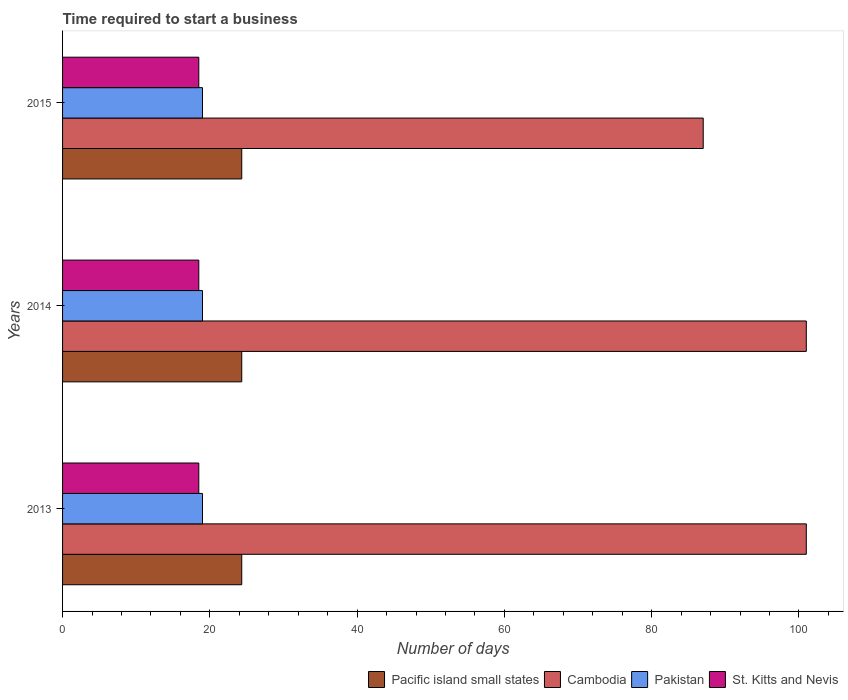Are the number of bars on each tick of the Y-axis equal?
Provide a succinct answer. Yes. How many bars are there on the 2nd tick from the top?
Provide a succinct answer. 4. How many bars are there on the 2nd tick from the bottom?
Provide a succinct answer. 4. What is the label of the 2nd group of bars from the top?
Provide a short and direct response. 2014. In how many cases, is the number of bars for a given year not equal to the number of legend labels?
Provide a short and direct response. 0. What is the number of days required to start a business in Cambodia in 2015?
Your answer should be very brief. 87. Across all years, what is the minimum number of days required to start a business in Pacific island small states?
Provide a succinct answer. 24.33. In which year was the number of days required to start a business in Pacific island small states maximum?
Your answer should be very brief. 2013. What is the total number of days required to start a business in St. Kitts and Nevis in the graph?
Your response must be concise. 55.5. What is the difference between the number of days required to start a business in Pakistan in 2013 and that in 2014?
Your response must be concise. 0. What is the average number of days required to start a business in Pakistan per year?
Provide a succinct answer. 19. In the year 2014, what is the difference between the number of days required to start a business in Pacific island small states and number of days required to start a business in St. Kitts and Nevis?
Your answer should be very brief. 5.83. In how many years, is the number of days required to start a business in Pakistan greater than 32 days?
Keep it short and to the point. 0. Is the number of days required to start a business in Pacific island small states in 2013 less than that in 2015?
Give a very brief answer. No. Is the difference between the number of days required to start a business in Pacific island small states in 2013 and 2014 greater than the difference between the number of days required to start a business in St. Kitts and Nevis in 2013 and 2014?
Your answer should be very brief. No. What is the difference between the highest and the lowest number of days required to start a business in Cambodia?
Your response must be concise. 14. Is the sum of the number of days required to start a business in Cambodia in 2013 and 2014 greater than the maximum number of days required to start a business in St. Kitts and Nevis across all years?
Your answer should be very brief. Yes. What does the 2nd bar from the bottom in 2014 represents?
Provide a succinct answer. Cambodia. Are all the bars in the graph horizontal?
Keep it short and to the point. Yes. How many years are there in the graph?
Provide a succinct answer. 3. Does the graph contain grids?
Ensure brevity in your answer.  No. How many legend labels are there?
Offer a very short reply. 4. How are the legend labels stacked?
Your response must be concise. Horizontal. What is the title of the graph?
Offer a terse response. Time required to start a business. What is the label or title of the X-axis?
Your answer should be compact. Number of days. What is the label or title of the Y-axis?
Provide a succinct answer. Years. What is the Number of days in Pacific island small states in 2013?
Offer a very short reply. 24.33. What is the Number of days in Cambodia in 2013?
Your response must be concise. 101. What is the Number of days of Pakistan in 2013?
Make the answer very short. 19. What is the Number of days of St. Kitts and Nevis in 2013?
Your response must be concise. 18.5. What is the Number of days in Pacific island small states in 2014?
Keep it short and to the point. 24.33. What is the Number of days in Cambodia in 2014?
Offer a very short reply. 101. What is the Number of days of Pacific island small states in 2015?
Offer a terse response. 24.33. What is the Number of days in Cambodia in 2015?
Provide a short and direct response. 87. What is the Number of days of St. Kitts and Nevis in 2015?
Make the answer very short. 18.5. Across all years, what is the maximum Number of days of Pacific island small states?
Provide a short and direct response. 24.33. Across all years, what is the maximum Number of days in Cambodia?
Your answer should be compact. 101. Across all years, what is the maximum Number of days of Pakistan?
Offer a terse response. 19. Across all years, what is the maximum Number of days of St. Kitts and Nevis?
Offer a very short reply. 18.5. Across all years, what is the minimum Number of days of Pacific island small states?
Offer a terse response. 24.33. Across all years, what is the minimum Number of days in St. Kitts and Nevis?
Keep it short and to the point. 18.5. What is the total Number of days of Pacific island small states in the graph?
Offer a very short reply. 73. What is the total Number of days of Cambodia in the graph?
Keep it short and to the point. 289. What is the total Number of days in Pakistan in the graph?
Offer a terse response. 57. What is the total Number of days in St. Kitts and Nevis in the graph?
Give a very brief answer. 55.5. What is the difference between the Number of days of Cambodia in 2014 and that in 2015?
Your response must be concise. 14. What is the difference between the Number of days in Pakistan in 2014 and that in 2015?
Make the answer very short. 0. What is the difference between the Number of days in Pacific island small states in 2013 and the Number of days in Cambodia in 2014?
Offer a very short reply. -76.67. What is the difference between the Number of days in Pacific island small states in 2013 and the Number of days in Pakistan in 2014?
Provide a succinct answer. 5.33. What is the difference between the Number of days of Pacific island small states in 2013 and the Number of days of St. Kitts and Nevis in 2014?
Provide a short and direct response. 5.83. What is the difference between the Number of days in Cambodia in 2013 and the Number of days in Pakistan in 2014?
Your answer should be compact. 82. What is the difference between the Number of days of Cambodia in 2013 and the Number of days of St. Kitts and Nevis in 2014?
Your response must be concise. 82.5. What is the difference between the Number of days in Pacific island small states in 2013 and the Number of days in Cambodia in 2015?
Offer a very short reply. -62.67. What is the difference between the Number of days in Pacific island small states in 2013 and the Number of days in Pakistan in 2015?
Your answer should be compact. 5.33. What is the difference between the Number of days in Pacific island small states in 2013 and the Number of days in St. Kitts and Nevis in 2015?
Your answer should be very brief. 5.83. What is the difference between the Number of days of Cambodia in 2013 and the Number of days of Pakistan in 2015?
Keep it short and to the point. 82. What is the difference between the Number of days of Cambodia in 2013 and the Number of days of St. Kitts and Nevis in 2015?
Make the answer very short. 82.5. What is the difference between the Number of days in Pakistan in 2013 and the Number of days in St. Kitts and Nevis in 2015?
Provide a short and direct response. 0.5. What is the difference between the Number of days in Pacific island small states in 2014 and the Number of days in Cambodia in 2015?
Offer a very short reply. -62.67. What is the difference between the Number of days of Pacific island small states in 2014 and the Number of days of Pakistan in 2015?
Your answer should be compact. 5.33. What is the difference between the Number of days of Pacific island small states in 2014 and the Number of days of St. Kitts and Nevis in 2015?
Ensure brevity in your answer.  5.83. What is the difference between the Number of days of Cambodia in 2014 and the Number of days of Pakistan in 2015?
Give a very brief answer. 82. What is the difference between the Number of days in Cambodia in 2014 and the Number of days in St. Kitts and Nevis in 2015?
Your answer should be very brief. 82.5. What is the average Number of days of Pacific island small states per year?
Offer a very short reply. 24.33. What is the average Number of days of Cambodia per year?
Keep it short and to the point. 96.33. What is the average Number of days of Pakistan per year?
Keep it short and to the point. 19. In the year 2013, what is the difference between the Number of days of Pacific island small states and Number of days of Cambodia?
Your response must be concise. -76.67. In the year 2013, what is the difference between the Number of days in Pacific island small states and Number of days in Pakistan?
Provide a succinct answer. 5.33. In the year 2013, what is the difference between the Number of days of Pacific island small states and Number of days of St. Kitts and Nevis?
Provide a short and direct response. 5.83. In the year 2013, what is the difference between the Number of days of Cambodia and Number of days of St. Kitts and Nevis?
Your answer should be very brief. 82.5. In the year 2014, what is the difference between the Number of days of Pacific island small states and Number of days of Cambodia?
Your answer should be very brief. -76.67. In the year 2014, what is the difference between the Number of days in Pacific island small states and Number of days in Pakistan?
Make the answer very short. 5.33. In the year 2014, what is the difference between the Number of days of Pacific island small states and Number of days of St. Kitts and Nevis?
Offer a very short reply. 5.83. In the year 2014, what is the difference between the Number of days of Cambodia and Number of days of Pakistan?
Provide a short and direct response. 82. In the year 2014, what is the difference between the Number of days of Cambodia and Number of days of St. Kitts and Nevis?
Provide a short and direct response. 82.5. In the year 2015, what is the difference between the Number of days of Pacific island small states and Number of days of Cambodia?
Ensure brevity in your answer.  -62.67. In the year 2015, what is the difference between the Number of days of Pacific island small states and Number of days of Pakistan?
Keep it short and to the point. 5.33. In the year 2015, what is the difference between the Number of days of Pacific island small states and Number of days of St. Kitts and Nevis?
Provide a short and direct response. 5.83. In the year 2015, what is the difference between the Number of days of Cambodia and Number of days of St. Kitts and Nevis?
Make the answer very short. 68.5. What is the ratio of the Number of days in Pakistan in 2013 to that in 2014?
Your response must be concise. 1. What is the ratio of the Number of days in St. Kitts and Nevis in 2013 to that in 2014?
Make the answer very short. 1. What is the ratio of the Number of days in Cambodia in 2013 to that in 2015?
Provide a short and direct response. 1.16. What is the ratio of the Number of days of Pacific island small states in 2014 to that in 2015?
Offer a terse response. 1. What is the ratio of the Number of days of Cambodia in 2014 to that in 2015?
Provide a short and direct response. 1.16. What is the ratio of the Number of days in Pakistan in 2014 to that in 2015?
Ensure brevity in your answer.  1. What is the difference between the highest and the second highest Number of days of Pacific island small states?
Give a very brief answer. 0. What is the difference between the highest and the second highest Number of days in St. Kitts and Nevis?
Your answer should be compact. 0. What is the difference between the highest and the lowest Number of days in St. Kitts and Nevis?
Your answer should be very brief. 0. 